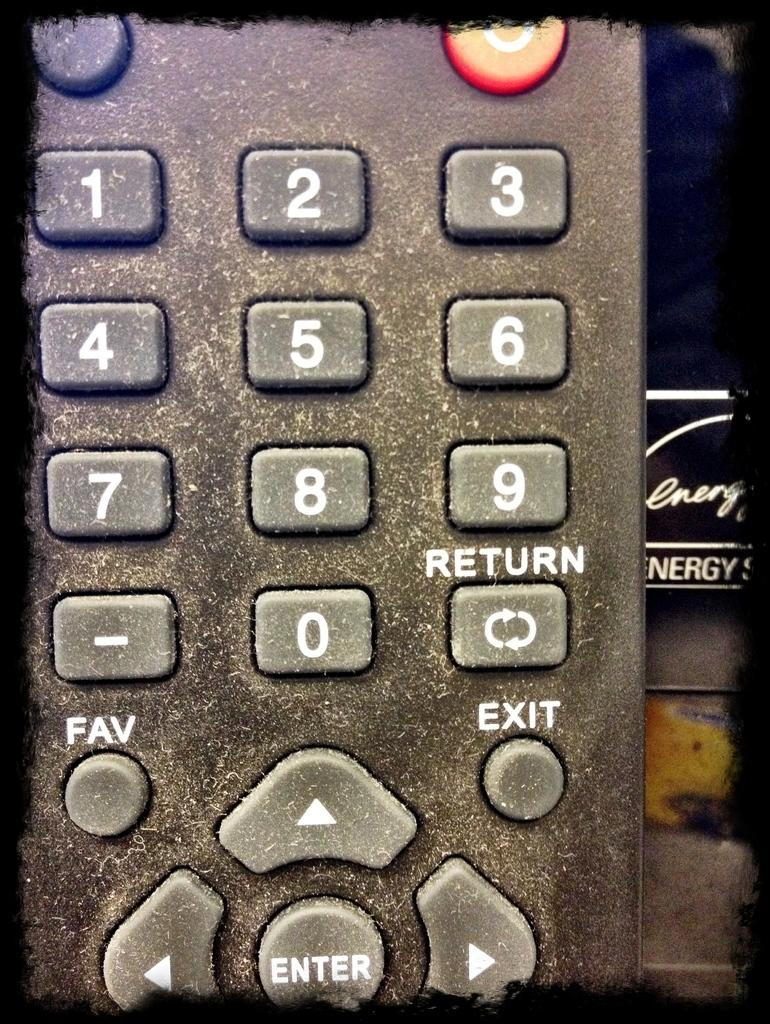<image>
Offer a succinct explanation of the picture presented. A dusty remote control is held in front of some literature on energy. 